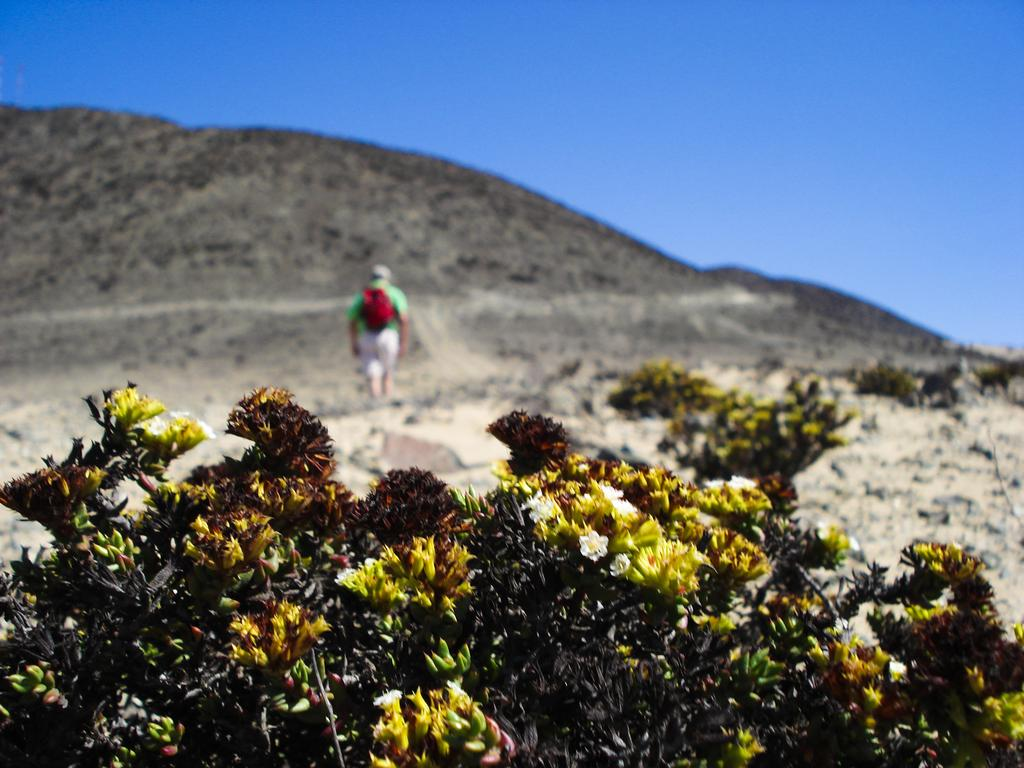What type of plants can be seen in the image? There are plants with flowers in the image. Can you describe the person in the image? There is a person standing in the image, and they are wearing a backpack bag. What color is the backpack bag? The backpack bag is red in color. What can be seen in the background of the image? There is a hill visible in the background of the image. What type of yarn is being used to decorate the plants in the image? There is no yarn present in the image; the plants are decorated with flowers. Can you tell me how many stalks of celery are visible in the image? There is no celery present in the image; it features plants with flowers. 